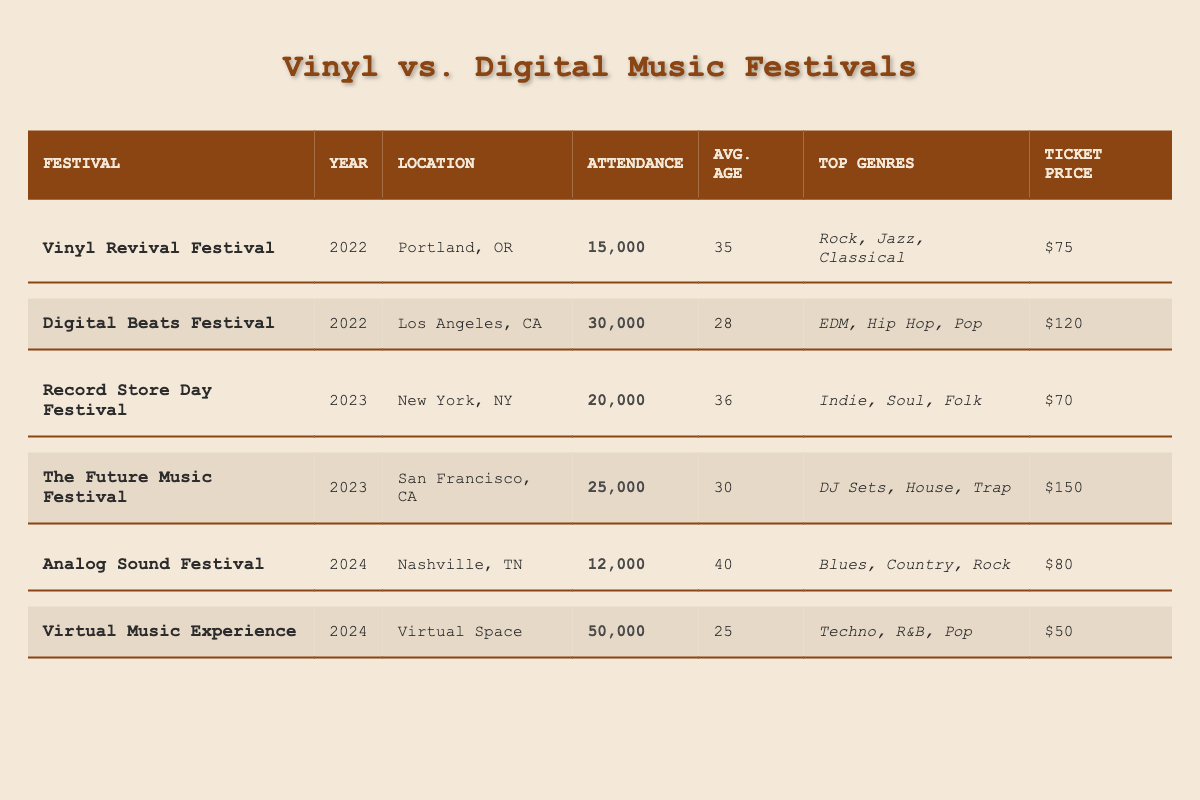What was the highest attendance at a vinyl-focused festival? The highest attendance at a vinyl-focused festival is found at the Record Store Day Festival with an attendance of 20,000.
Answer: 20,000 Which festival had the lowest ticket price? The festival with the lowest ticket price is the Virtual Music Experience, priced at $50.
Answer: $50 What is the average age of attendees at digital music festivals? To find the average age, sum the ages of the two digital festivals (28 + 30 + 25) = 83 and divide by 3: 83/3 = 27.67. So, the average age is approximately 28.
Answer: 28 Did any vinyl festival have an attendance greater than 15,000? Yes, both the Vinyl Revival Festival and the Record Store Day Festival had attendance greater than 15,000 with 15,000 and 20,000 respectively.
Answer: Yes Calculate the total attendance across all festivals in 2022. For 2022, sum the attendance: 15,000 (Vinyl Revival) + 30,000 (Digital Beats) = 45,000.
Answer: 45,000 What is the gender ratio of the Analog Sound Festival? The gender ratios provided in the table for the Analog Sound Festival are 52% male, 40% female, and 8% non-binary.
Answer: 52% male, 40% female, 8% non-binary Which festival had the highest ticket price? The festival with the highest ticket price is the Future Music Festival at $150.
Answer: $150 How many exhibition spaces were there at all digital music festivals combined? The digital festivals are Digital Beats (100 spaces), The Future Music Festival (80 spaces), and Virtual Music Experience (20 spaces). The total is 100 + 80 + 20 = 200 spaces.
Answer: 200 What is the difference in average age between the Vinyl Revival Festival and the Digital Beats Festival? The average age for the Vinyl Revival Festival is 35 and for Digital Beats Festival, it is 28. The difference is 35 - 28 = 7 years.
Answer: 7 years Was the attendance at the Analog Sound Festival higher than 10,000? Yes, the Analog Sound Festival had an attendance of 12,000, which is higher than 10,000.
Answer: Yes What is the average ticket price for vinyl music festivals? The ticket prices for the vinyl festivals are $75 (Vinyl Revival), $70 (Record Store Day), and $80 (Analog Sound). The total ticket price is 75 + 70 + 80 = 225. Thus, average is 225/3 = 75.
Answer: $75 Which top genre was popular in both vinyl-focused festivals? The genre "Rock" was popular at both Vinyl Revival Festival and Analog Sound Festival.
Answer: Rock 